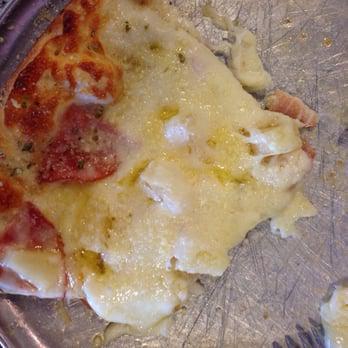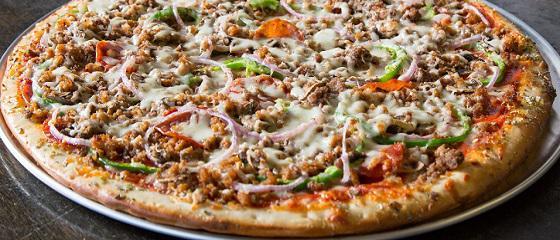The first image is the image on the left, the second image is the image on the right. Evaluate the accuracy of this statement regarding the images: "The right image shows one round pizza with no slices missingon a round silver tray, and the left image shows at least part of a pizza smothered in white cheese on a round silver tray.". Is it true? Answer yes or no. Yes. The first image is the image on the left, the second image is the image on the right. Evaluate the accuracy of this statement regarding the images: "In at least one image there is a single slice of pizza on a sliver pizza tray.". Is it true? Answer yes or no. No. 